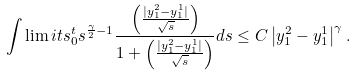<formula> <loc_0><loc_0><loc_500><loc_500>\int \lim i t s _ { 0 } ^ { t } s ^ { \frac { \gamma } { 2 } - 1 } \frac { \left ( \frac { | y ^ { 2 } _ { 1 } - y ^ { 1 } _ { 1 } | } { \sqrt { s } } \right ) } { 1 + \left ( \frac { | y ^ { 2 } _ { 1 } - y ^ { 1 } _ { 1 } | } { \sqrt { s } } \right ) } d s \leq C \left | y ^ { 2 } _ { 1 } - y ^ { 1 } _ { 1 } \right | ^ { \gamma } .</formula> 